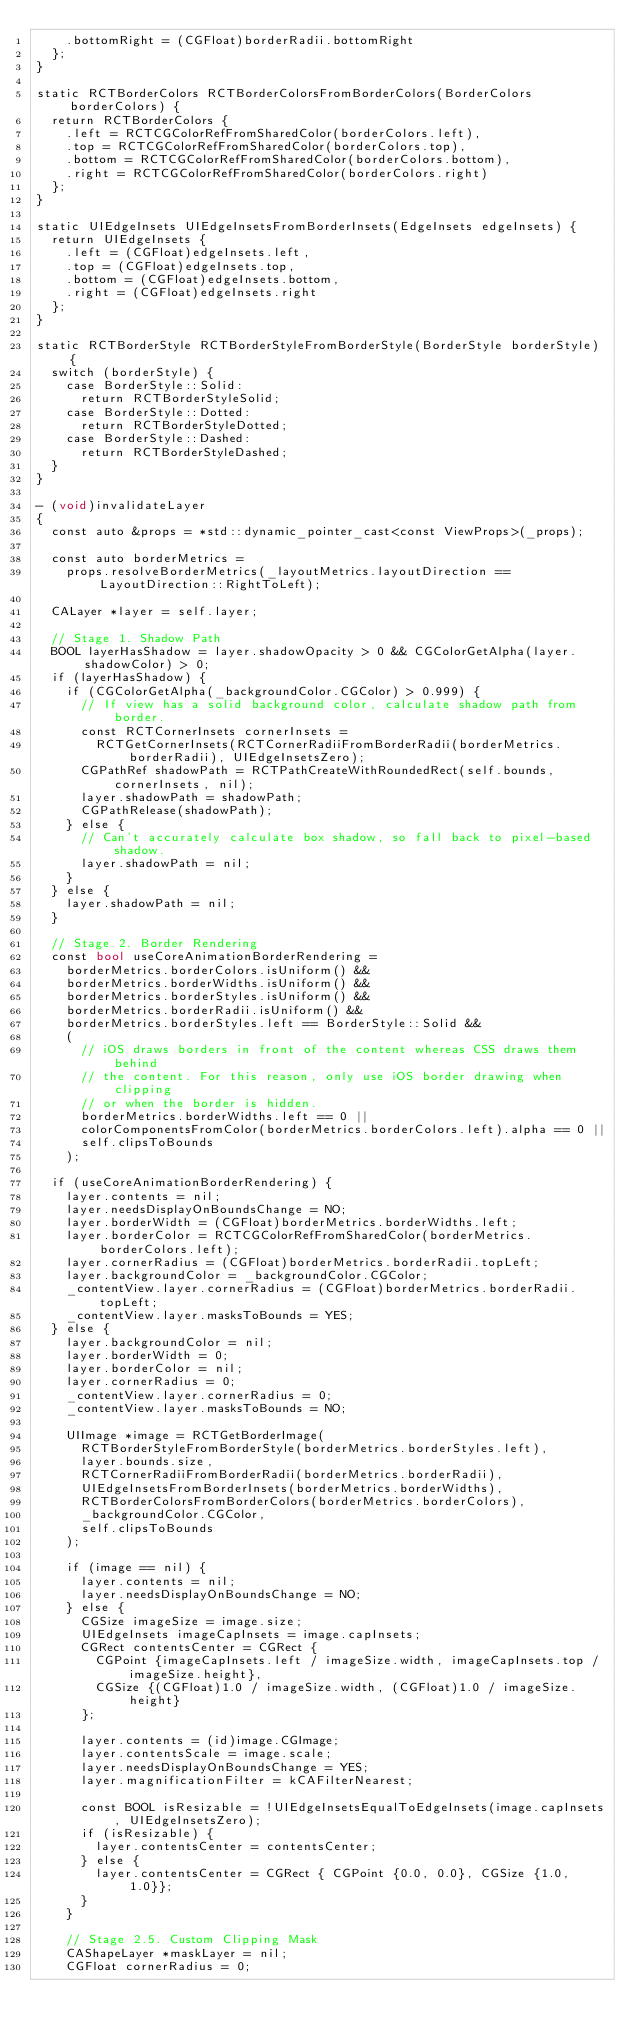Convert code to text. <code><loc_0><loc_0><loc_500><loc_500><_ObjectiveC_>    .bottomRight = (CGFloat)borderRadii.bottomRight
  };
}

static RCTBorderColors RCTBorderColorsFromBorderColors(BorderColors borderColors) {
  return RCTBorderColors {
    .left = RCTCGColorRefFromSharedColor(borderColors.left),
    .top = RCTCGColorRefFromSharedColor(borderColors.top),
    .bottom = RCTCGColorRefFromSharedColor(borderColors.bottom),
    .right = RCTCGColorRefFromSharedColor(borderColors.right)
  };
}

static UIEdgeInsets UIEdgeInsetsFromBorderInsets(EdgeInsets edgeInsets) {
  return UIEdgeInsets {
    .left = (CGFloat)edgeInsets.left,
    .top = (CGFloat)edgeInsets.top,
    .bottom = (CGFloat)edgeInsets.bottom,
    .right = (CGFloat)edgeInsets.right
  };
}

static RCTBorderStyle RCTBorderStyleFromBorderStyle(BorderStyle borderStyle) {
  switch (borderStyle) {
    case BorderStyle::Solid:
      return RCTBorderStyleSolid;
    case BorderStyle::Dotted:
      return RCTBorderStyleDotted;
    case BorderStyle::Dashed:
      return RCTBorderStyleDashed;
  }
}

- (void)invalidateLayer
{
  const auto &props = *std::dynamic_pointer_cast<const ViewProps>(_props);

  const auto borderMetrics =
    props.resolveBorderMetrics(_layoutMetrics.layoutDirection == LayoutDirection::RightToLeft);

  CALayer *layer = self.layer;

  // Stage 1. Shadow Path
  BOOL layerHasShadow = layer.shadowOpacity > 0 && CGColorGetAlpha(layer.shadowColor) > 0;
  if (layerHasShadow) {
    if (CGColorGetAlpha(_backgroundColor.CGColor) > 0.999) {
      // If view has a solid background color, calculate shadow path from border.
      const RCTCornerInsets cornerInsets =
        RCTGetCornerInsets(RCTCornerRadiiFromBorderRadii(borderMetrics.borderRadii), UIEdgeInsetsZero);
      CGPathRef shadowPath = RCTPathCreateWithRoundedRect(self.bounds, cornerInsets, nil);
      layer.shadowPath = shadowPath;
      CGPathRelease(shadowPath);
    } else {
      // Can't accurately calculate box shadow, so fall back to pixel-based shadow.
      layer.shadowPath = nil;
    }
  } else {
    layer.shadowPath = nil;
  }

  // Stage 2. Border Rendering
  const bool useCoreAnimationBorderRendering =
    borderMetrics.borderColors.isUniform() &&
    borderMetrics.borderWidths.isUniform() &&
    borderMetrics.borderStyles.isUniform() &&
    borderMetrics.borderRadii.isUniform() &&
    borderMetrics.borderStyles.left == BorderStyle::Solid &&
    (
      // iOS draws borders in front of the content whereas CSS draws them behind
      // the content. For this reason, only use iOS border drawing when clipping
      // or when the border is hidden.
      borderMetrics.borderWidths.left == 0 ||
      colorComponentsFromColor(borderMetrics.borderColors.left).alpha == 0 ||
      self.clipsToBounds
    );

  if (useCoreAnimationBorderRendering) {
    layer.contents = nil;
    layer.needsDisplayOnBoundsChange = NO;
    layer.borderWidth = (CGFloat)borderMetrics.borderWidths.left;
    layer.borderColor = RCTCGColorRefFromSharedColor(borderMetrics.borderColors.left);
    layer.cornerRadius = (CGFloat)borderMetrics.borderRadii.topLeft;
    layer.backgroundColor = _backgroundColor.CGColor;
    _contentView.layer.cornerRadius = (CGFloat)borderMetrics.borderRadii.topLeft;
    _contentView.layer.masksToBounds = YES;
  } else {
    layer.backgroundColor = nil;
    layer.borderWidth = 0;
    layer.borderColor = nil;
    layer.cornerRadius = 0;
    _contentView.layer.cornerRadius = 0;
    _contentView.layer.masksToBounds = NO;

    UIImage *image = RCTGetBorderImage(
      RCTBorderStyleFromBorderStyle(borderMetrics.borderStyles.left),
      layer.bounds.size,
      RCTCornerRadiiFromBorderRadii(borderMetrics.borderRadii),
      UIEdgeInsetsFromBorderInsets(borderMetrics.borderWidths),
      RCTBorderColorsFromBorderColors(borderMetrics.borderColors),
      _backgroundColor.CGColor,
      self.clipsToBounds
    );

    if (image == nil) {
      layer.contents = nil;
      layer.needsDisplayOnBoundsChange = NO;
    } else {
      CGSize imageSize = image.size;
      UIEdgeInsets imageCapInsets = image.capInsets;
      CGRect contentsCenter = CGRect {
        CGPoint {imageCapInsets.left / imageSize.width, imageCapInsets.top / imageSize.height},
        CGSize {(CGFloat)1.0 / imageSize.width, (CGFloat)1.0 / imageSize.height}
      };

      layer.contents = (id)image.CGImage;
      layer.contentsScale = image.scale;
      layer.needsDisplayOnBoundsChange = YES;
      layer.magnificationFilter = kCAFilterNearest;

      const BOOL isResizable = !UIEdgeInsetsEqualToEdgeInsets(image.capInsets, UIEdgeInsetsZero);
      if (isResizable) {
        layer.contentsCenter = contentsCenter;
      } else {
        layer.contentsCenter = CGRect { CGPoint {0.0, 0.0}, CGSize {1.0, 1.0}};
      }
    }

    // Stage 2.5. Custom Clipping Mask
    CAShapeLayer *maskLayer = nil;
    CGFloat cornerRadius = 0;</code> 